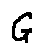Convert formula to latex. <formula><loc_0><loc_0><loc_500><loc_500>G</formula> 